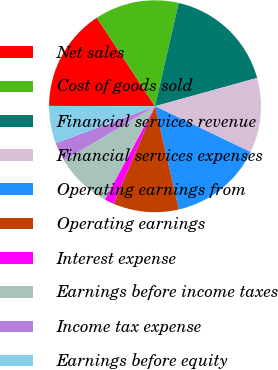Convert chart to OTSL. <chart><loc_0><loc_0><loc_500><loc_500><pie_chart><fcel>Net sales<fcel>Cost of goods sold<fcel>Financial services revenue<fcel>Financial services expenses<fcel>Operating earnings from<fcel>Operating earnings<fcel>Interest expense<fcel>Earnings before income taxes<fcel>Income tax expense<fcel>Earnings before equity<nl><fcel>15.69%<fcel>12.84%<fcel>17.11%<fcel>11.42%<fcel>14.27%<fcel>10.0%<fcel>1.47%<fcel>8.58%<fcel>2.89%<fcel>5.73%<nl></chart> 